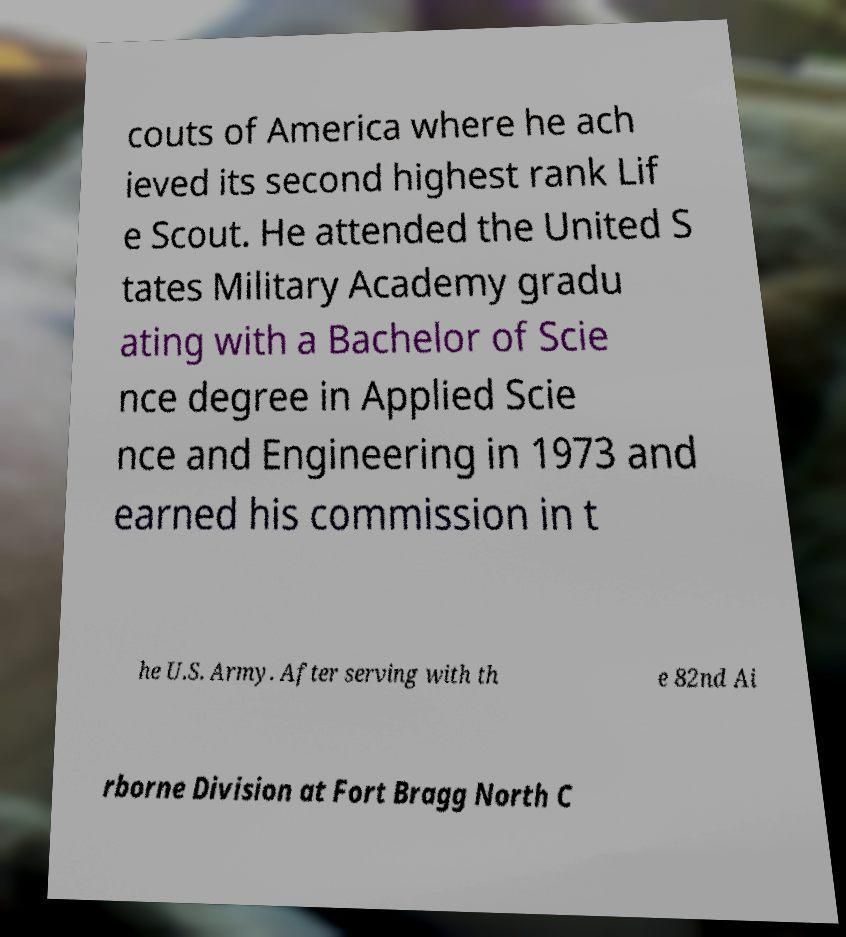Can you accurately transcribe the text from the provided image for me? couts of America where he ach ieved its second highest rank Lif e Scout. He attended the United S tates Military Academy gradu ating with a Bachelor of Scie nce degree in Applied Scie nce and Engineering in 1973 and earned his commission in t he U.S. Army. After serving with th e 82nd Ai rborne Division at Fort Bragg North C 